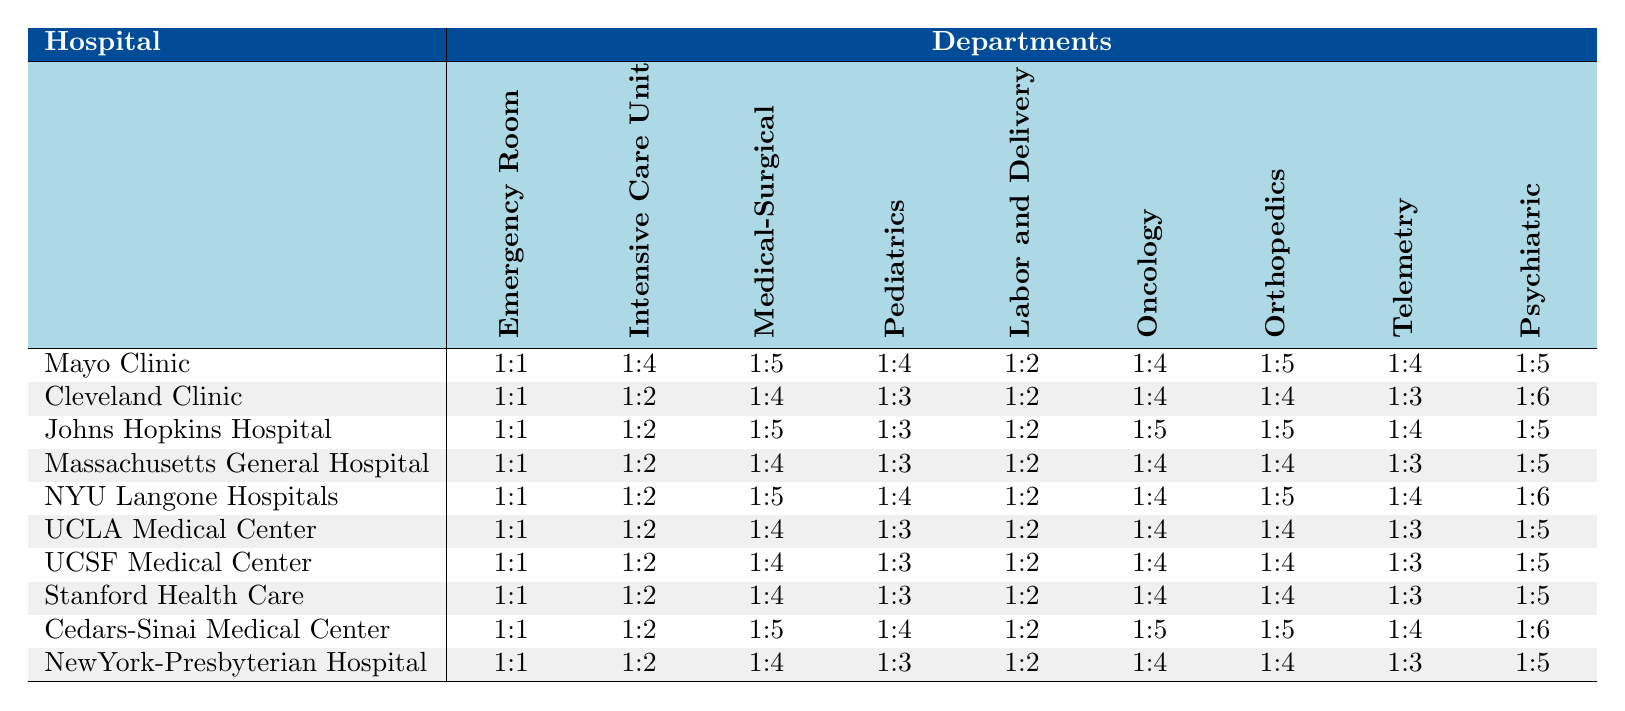What is the nurse-to-patient ratio in the Emergency Room for Mayo Clinic? The table shows that the nurse-to-patient ratio for the Emergency Room at Mayo Clinic is 1:1.
Answer: 1:1 Which department has the highest nurse-to-patient ratio at Johns Hopkins Hospital? Looking at the nursing ratios for Johns Hopkins Hospital, the highest ratio is in the Medical-Surgical department at 1:5.
Answer: Medical-Surgical Is the nurse-to-patient ratio in the Intensive Care Unit higher in NewYork-Presbyterian Hospital than in UCSF Medical Center? According to the table, NewYork-Presbyterian Hospital has a ratio of 1:2 and UCSF Medical Center also has a ratio of 1:2, so they are equal.
Answer: No What is the average nurse-to-patient ratio for the Oncology department across all hospitals? To find the average for the Oncology department, we add all the ratios: (4 + 4 + 5 + 4 + 4 + 4 + 4 + 5 + 5 + 4) = 4.4, and there are 10 hospitals, so the average is 44/10 = 4.4.
Answer: 4.4 Which hospital has the lowest nurse-to-patient ratio in the Labor and Delivery department? Upon reviewing the table, the lowest ratio for Labor and Delivery is at Mayo Clinic, which has a ratio of 1:2.
Answer: Mayo Clinic For which department is the nurse-to-patient ratio the same across all hospitals? Analyzing the table, the Telemetry department has a consistent ratio of 1:4 across all hospitals.
Answer: Telemetry How does the nurse-to-patient ratio in Pediatrics at NYU Langone Hospitals compare with that at Massachusetts General Hospital? NYU Langone Hospitals has a ratio of 1:4 in Pediatrics, while Massachusetts General Hospital has a ratio of 1:3. Therefore, NYU Langone Hospitals has a higher ratio.
Answer: NYU Langone Hospitals What is the difference between the highest and lowest nurse-to-patient ratio in the Psychiatric department across all hospitals? The highest ratio in the Psychiatric department is 1:6 (Cleveland Clinic), and the lowest is 1:3 (most hospitals). To find the difference: 6 - 3 = 3.
Answer: 3 Which two hospitals have the same nurse-to-patient ratio in the Medical-Surgical department, and what is that ratio? By reviewing the ratios for the Medical-Surgical department, both Mayo Clinic and Johns Hopkins Hospital have the same ratio of 1:5.
Answer: 1:5 (Mayo Clinic and Johns Hopkins Hospital) What is the trend for nurse-to-patient ratios in the Intensive Care Unit across the hospitals listed? Examining the ratios, they consistently show a trend of 1:2 for five hospitals, 1:3 for two hospitals, and 1:4 for two hospitals, indicating variability but most commonly a lower ratio of 1:2.
Answer: Mixed, primarily 1:2 